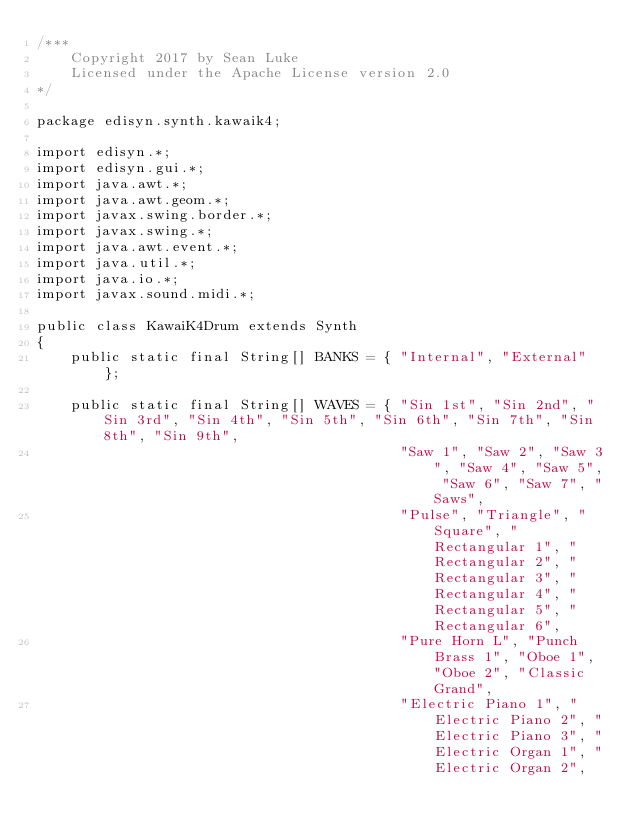<code> <loc_0><loc_0><loc_500><loc_500><_Java_>/***
    Copyright 2017 by Sean Luke
    Licensed under the Apache License version 2.0
*/

package edisyn.synth.kawaik4;

import edisyn.*;
import edisyn.gui.*;
import java.awt.*;
import java.awt.geom.*;
import javax.swing.border.*;
import javax.swing.*;
import java.awt.event.*;
import java.util.*;
import java.io.*;
import javax.sound.midi.*;

public class KawaiK4Drum extends Synth
{
    public static final String[] BANKS = { "Internal", "External" };

    public static final String[] WAVES = { "Sin 1st", "Sin 2nd", "Sin 3rd", "Sin 4th", "Sin 5th", "Sin 6th", "Sin 7th", "Sin 8th", "Sin 9th", 
                                           "Saw 1", "Saw 2", "Saw 3", "Saw 4", "Saw 5", "Saw 6", "Saw 7", "Saws", 
                                           "Pulse", "Triangle", "Square", "Rectangular 1", "Rectangular 2", "Rectangular 3", "Rectangular 4", "Rectangular 5", "Rectangular 6", 
                                           "Pure Horn L", "Punch Brass 1", "Oboe 1", "Oboe 2", "Classic Grand", 
                                           "Electric Piano 1", "Electric Piano 2", "Electric Piano 3", "Electric Organ 1", "Electric Organ 2", </code> 